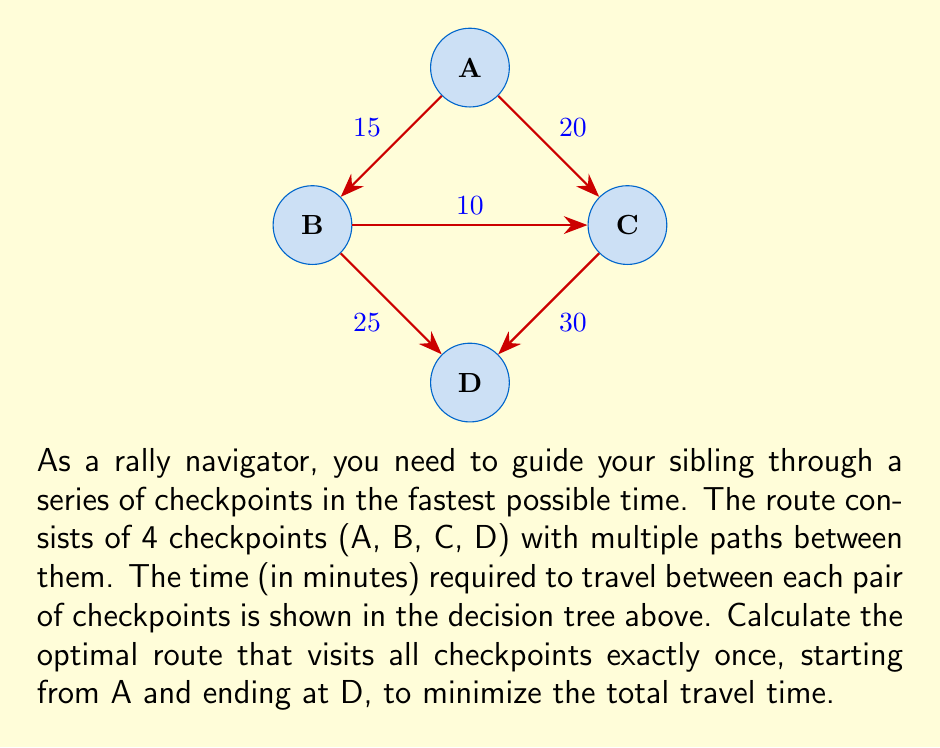What is the answer to this math problem? Let's approach this step-by-step using a decision tree:

1) We start at A and must end at D, visiting B and C in between. There are two possible routes:
   A → B → C → D
   A → C → B → D

2) Let's calculate the time for each route:

   Route 1: A → B → C → D
   $$ T_1 = T_{AB} + T_{BC} + T_{CD} = 15 + 10 + 30 = 55 \text{ minutes} $$

   Route 2: A → C → B → D
   $$ T_2 = T_{AC} + T_{CB} + T_{BD} = 20 + 10 + 25 = 55 \text{ minutes} $$

3) Both routes take the same amount of time. In this case, we can choose either route as the optimal solution.

4) To verify, let's check if there are any other possible routes:
   - We can't go directly from A to D
   - We can't revisit any checkpoint
   - We must visit all checkpoints

   This confirms that these are the only two possible routes.

5) Therefore, the optimal route can be either:
   A → B → C → D
   or
   A → C → B → D

Both routes result in a minimum total travel time of 55 minutes.
Answer: A → B → C → D or A → C → B → D, 55 minutes 